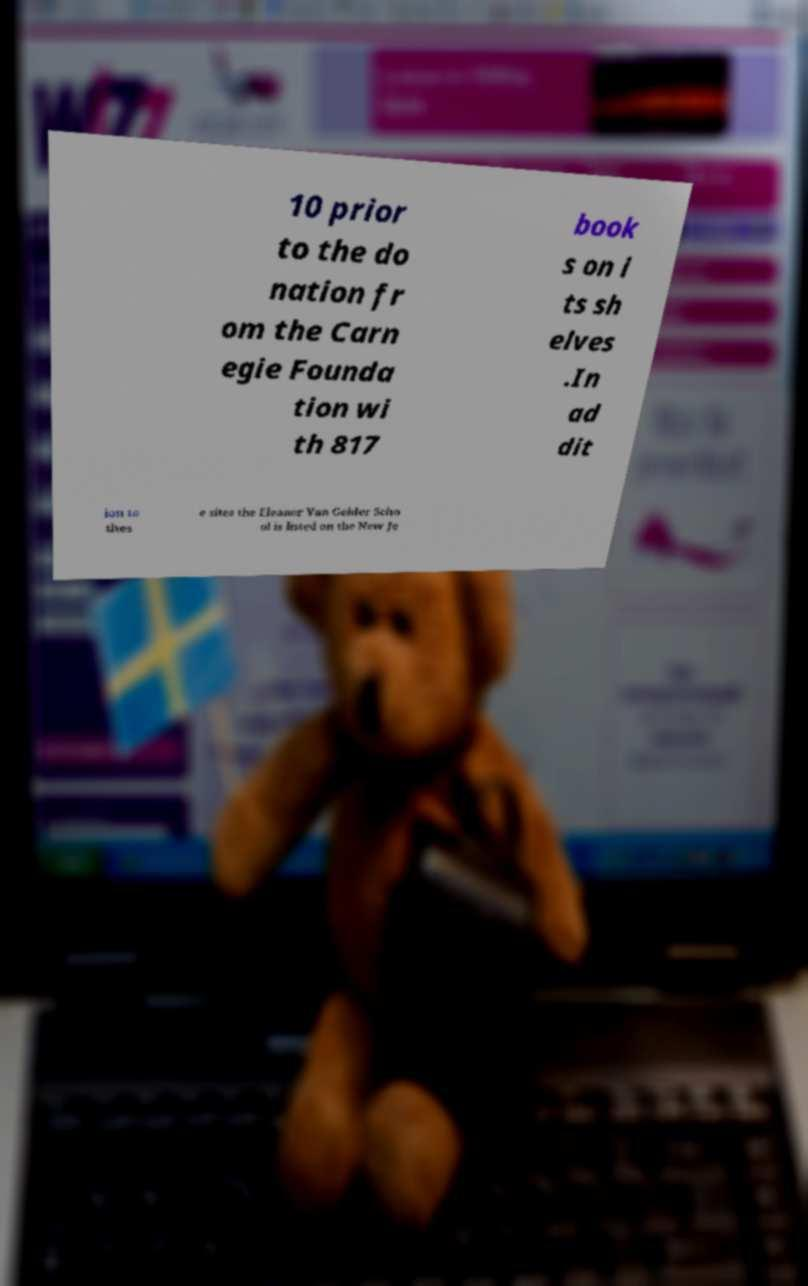There's text embedded in this image that I need extracted. Can you transcribe it verbatim? 10 prior to the do nation fr om the Carn egie Founda tion wi th 817 book s on i ts sh elves .In ad dit ion to thes e sites the Eleanor Van Gelder Scho ol is listed on the New Je 